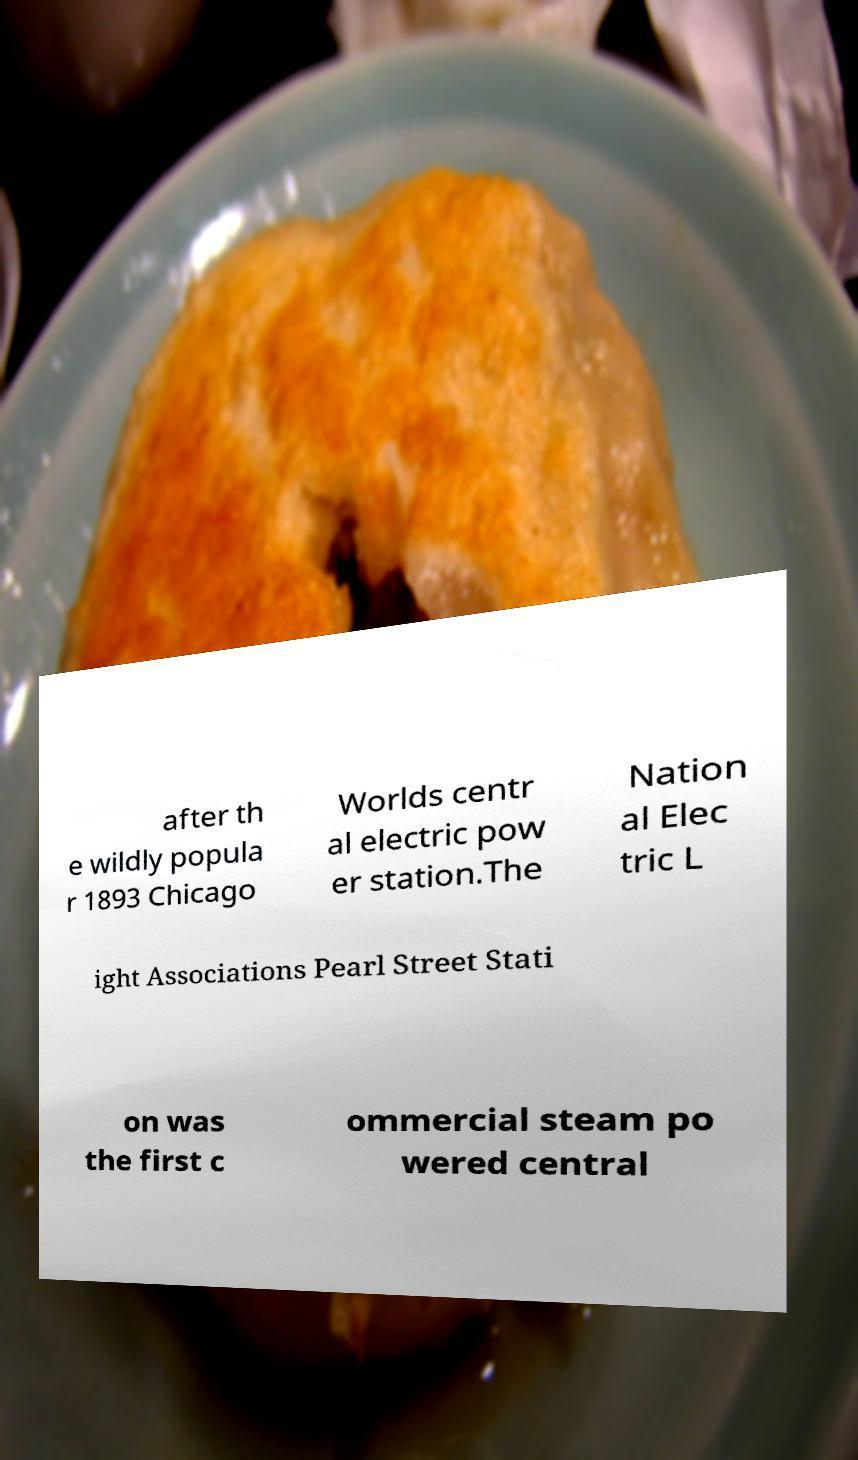Can you read and provide the text displayed in the image?This photo seems to have some interesting text. Can you extract and type it out for me? after th e wildly popula r 1893 Chicago Worlds centr al electric pow er station.The Nation al Elec tric L ight Associations Pearl Street Stati on was the first c ommercial steam po wered central 